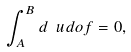<formula> <loc_0><loc_0><loc_500><loc_500>\int _ { A } ^ { B } d \ u d o f = 0 ,</formula> 